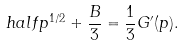<formula> <loc_0><loc_0><loc_500><loc_500>\ h a l f p ^ { 1 / 2 } + \frac { B } { 3 } = \frac { 1 } { 3 } G ^ { \prime } ( p ) .</formula> 